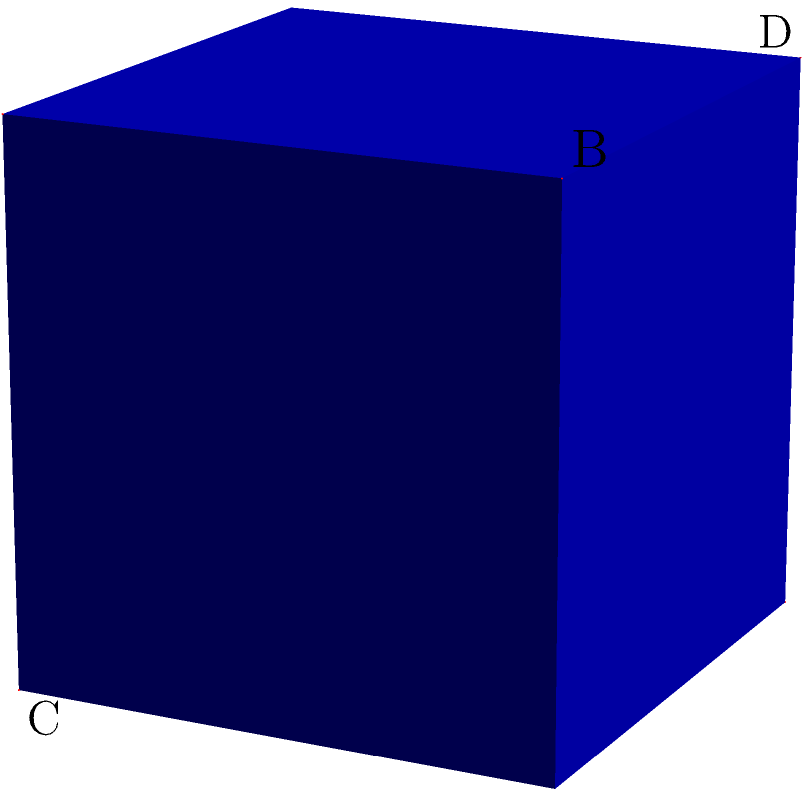In the structural analysis of ancient texts, scholars often encounter geometric patterns. Consider a cube ABCDEFGH, where A is at (0,0,0) and G is at (1,1,1). Three planes intersect at the center of the cube, each passing through two opposite vertices: ABG, ACG, and ADG. What is the angle between any two of these planes? Let's approach this step-by-step:

1) First, we need to understand that the planes ABG, ACG, and ADG are diagonal planes of the cube, each passing through the cube's center.

2) The angle between two planes is equal to the angle between their normal vectors.

3) To find the normal vectors, we can use the cross product of two vectors lying on each plane:
   - For plane ABG: $\vec{n_1} = \vec{AB} \times \vec{AG} = (1,0,0) \times (1,1,1) = (0,-1,1)$
   - For plane ACG: $\vec{n_2} = \vec{AC} \times \vec{AG} = (0,1,0) \times (1,1,1) = (1,0,-1)$
   - For plane ADG: $\vec{n_3} = \vec{AD} \times \vec{AG} = (0,0,1) \times (1,1,1) = (-1,1,0)$

4) The angle $\theta$ between two planes can be found using the dot product formula:

   $$\cos \theta = \frac{\vec{n_1} \cdot \vec{n_2}}{|\vec{n_1}||\vec{n_2}|}$$

5) Let's calculate for $\vec{n_1}$ and $\vec{n_2}$:
   
   $$\cos \theta = \frac{(0,-1,1) \cdot (1,0,-1)}{\sqrt{2}\sqrt{2}} = \frac{-1}{2}$$

6) Taking the inverse cosine:

   $$\theta = \arccos(-\frac{1}{2}) = 120°$$

7) This angle is the same for any pair of these planes due to the symmetry of the cube.
Answer: 120° 